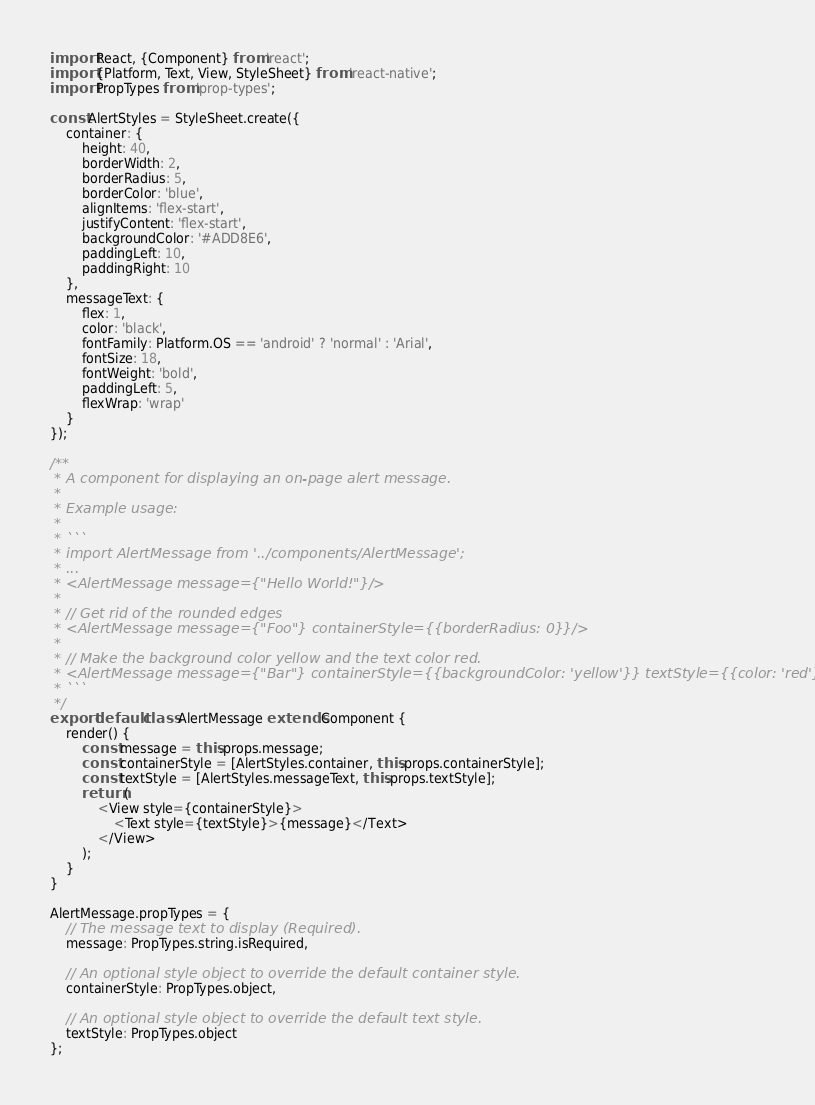Convert code to text. <code><loc_0><loc_0><loc_500><loc_500><_JavaScript_>import React, {Component} from 'react';
import {Platform, Text, View, StyleSheet} from 'react-native';
import PropTypes from 'prop-types';

const AlertStyles = StyleSheet.create({
    container: {
        height: 40,
        borderWidth: 2,
        borderRadius: 5,
        borderColor: 'blue',
        alignItems: 'flex-start',
        justifyContent: 'flex-start',
        backgroundColor: '#ADD8E6',
        paddingLeft: 10,
        paddingRight: 10
    },
    messageText: {
        flex: 1,
        color: 'black',
        fontFamily: Platform.OS == 'android' ? 'normal' : 'Arial',
        fontSize: 18,
        fontWeight: 'bold',
        paddingLeft: 5,
        flexWrap: 'wrap'
    }
});

/**
 * A component for displaying an on-page alert message.
 * 
 * Example usage:
 * 
 * ```
 * import AlertMessage from '../components/AlertMessage';
 * ...
 * <AlertMessage message={"Hello World!"}/>
 * 
 * // Get rid of the rounded edges
 * <AlertMessage message={"Foo"} containerStyle={{borderRadius: 0}}/>
 * 
 * // Make the background color yellow and the text color red.
 * <AlertMessage message={"Bar"} containerStyle={{backgroundColor: 'yellow'}} textStyle={{color: 'red'}}/>
 * ```
 */
export default class AlertMessage extends Component {
    render() {
        const message = this.props.message;
        const containerStyle = [AlertStyles.container, this.props.containerStyle];
        const textStyle = [AlertStyles.messageText, this.props.textStyle];
        return (
            <View style={containerStyle}>
                <Text style={textStyle}>{message}</Text>
            </View>
        );
    }
}

AlertMessage.propTypes = {
    // The message text to display (Required).
    message: PropTypes.string.isRequired,

    // An optional style object to override the default container style.
    containerStyle: PropTypes.object,

    // An optional style object to override the default text style.
    textStyle: PropTypes.object
};</code> 